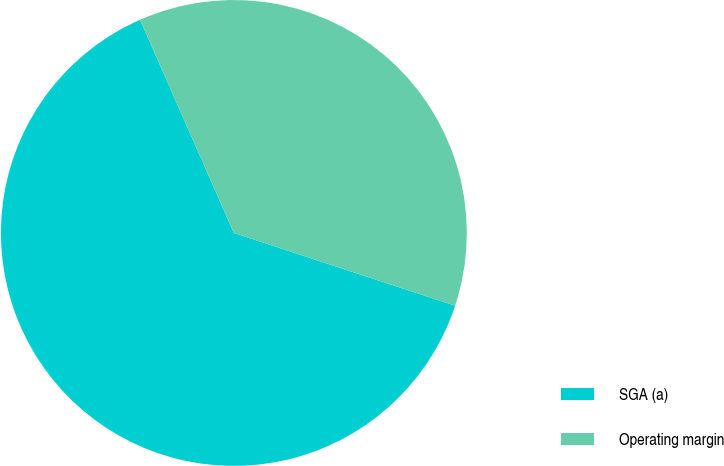<chart> <loc_0><loc_0><loc_500><loc_500><pie_chart><fcel>SGA (a)<fcel>Operating margin<nl><fcel>63.35%<fcel>36.65%<nl></chart> 